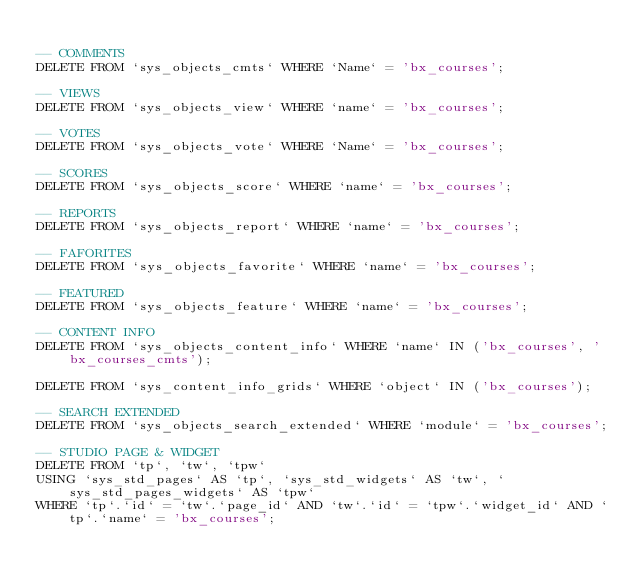<code> <loc_0><loc_0><loc_500><loc_500><_SQL_>
-- COMMENTS
DELETE FROM `sys_objects_cmts` WHERE `Name` = 'bx_courses';

-- VIEWS
DELETE FROM `sys_objects_view` WHERE `name` = 'bx_courses';

-- VOTES
DELETE FROM `sys_objects_vote` WHERE `Name` = 'bx_courses';

-- SCORES
DELETE FROM `sys_objects_score` WHERE `name` = 'bx_courses';

-- REPORTS
DELETE FROM `sys_objects_report` WHERE `name` = 'bx_courses';

-- FAFORITES
DELETE FROM `sys_objects_favorite` WHERE `name` = 'bx_courses';

-- FEATURED
DELETE FROM `sys_objects_feature` WHERE `name` = 'bx_courses';

-- CONTENT INFO
DELETE FROM `sys_objects_content_info` WHERE `name` IN ('bx_courses', 'bx_courses_cmts');

DELETE FROM `sys_content_info_grids` WHERE `object` IN ('bx_courses');

-- SEARCH EXTENDED
DELETE FROM `sys_objects_search_extended` WHERE `module` = 'bx_courses';

-- STUDIO PAGE & WIDGET
DELETE FROM `tp`, `tw`, `tpw`
USING `sys_std_pages` AS `tp`, `sys_std_widgets` AS `tw`, `sys_std_pages_widgets` AS `tpw`
WHERE `tp`.`id` = `tw`.`page_id` AND `tw`.`id` = `tpw`.`widget_id` AND `tp`.`name` = 'bx_courses';

</code> 